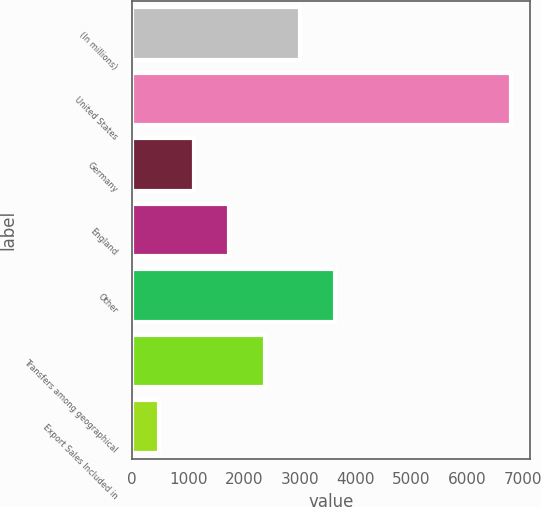Convert chart to OTSL. <chart><loc_0><loc_0><loc_500><loc_500><bar_chart><fcel>(In millions)<fcel>United States<fcel>Germany<fcel>England<fcel>Other<fcel>Transfers among geographical<fcel>Export Sales Included in<nl><fcel>3000.26<fcel>6784.4<fcel>1108.19<fcel>1738.88<fcel>3630.95<fcel>2369.57<fcel>477.5<nl></chart> 